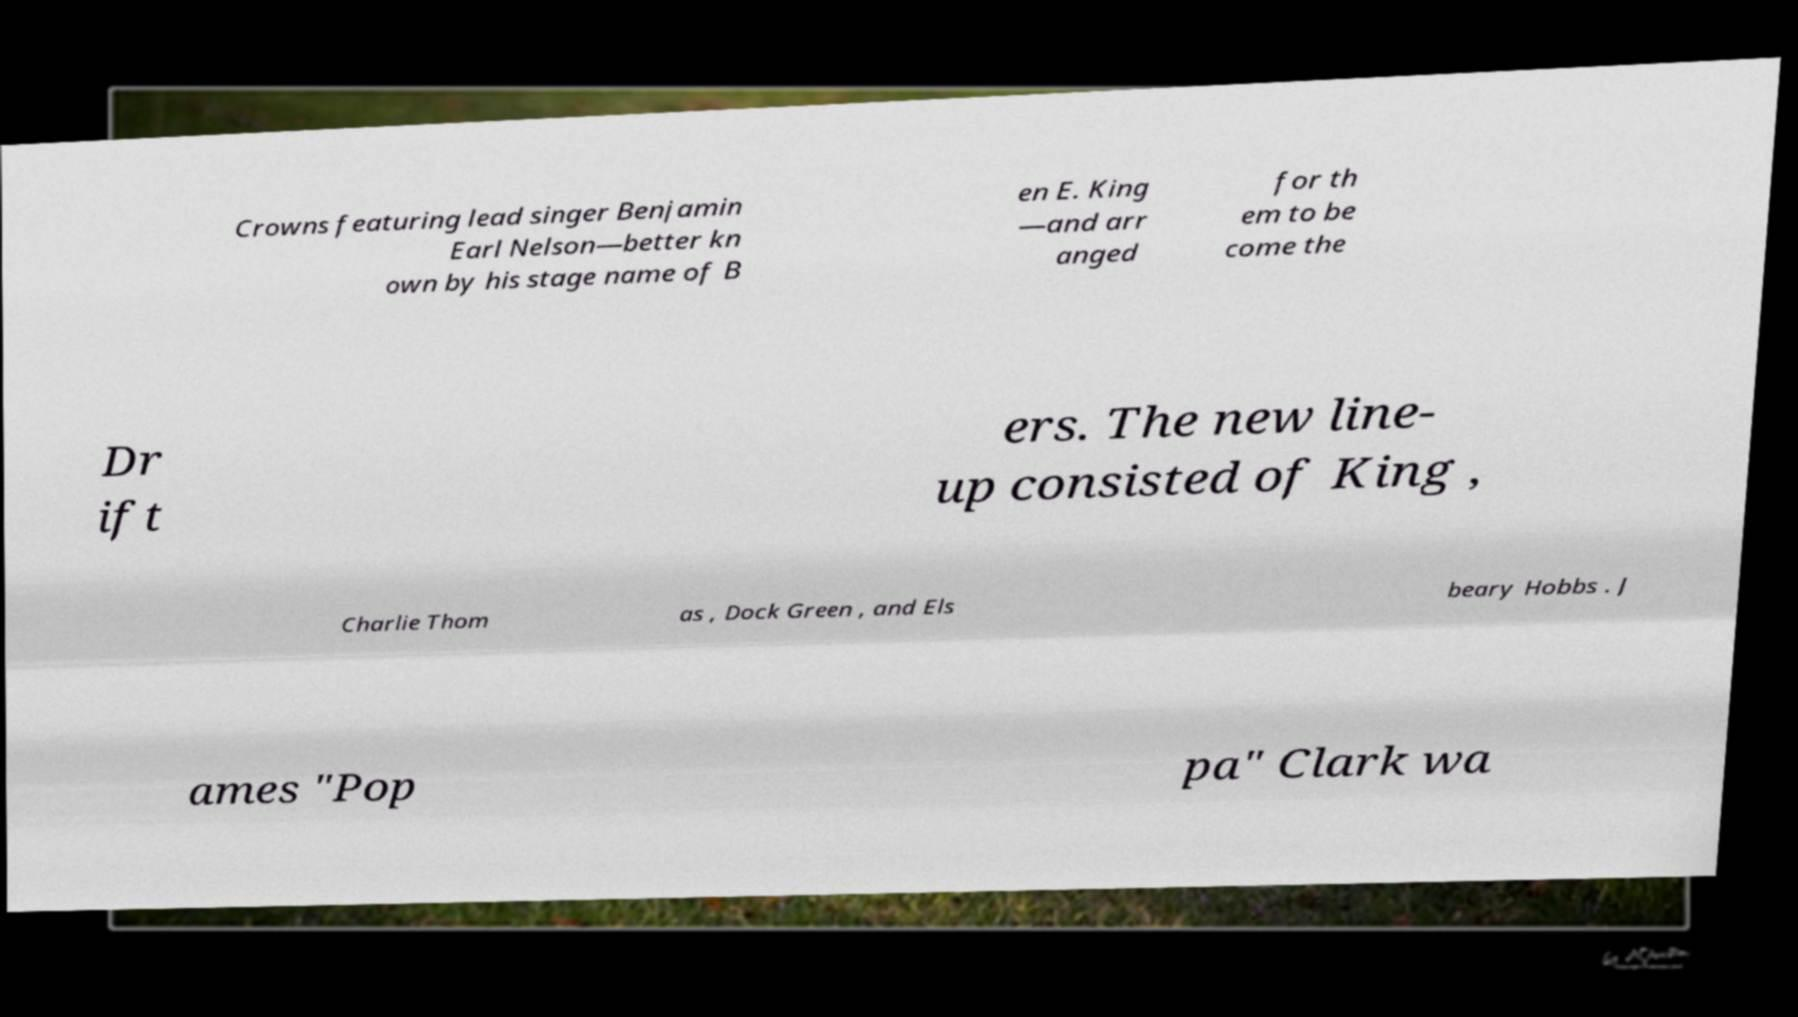Could you assist in decoding the text presented in this image and type it out clearly? Crowns featuring lead singer Benjamin Earl Nelson—better kn own by his stage name of B en E. King —and arr anged for th em to be come the Dr ift ers. The new line- up consisted of King , Charlie Thom as , Dock Green , and Els beary Hobbs . J ames "Pop pa" Clark wa 